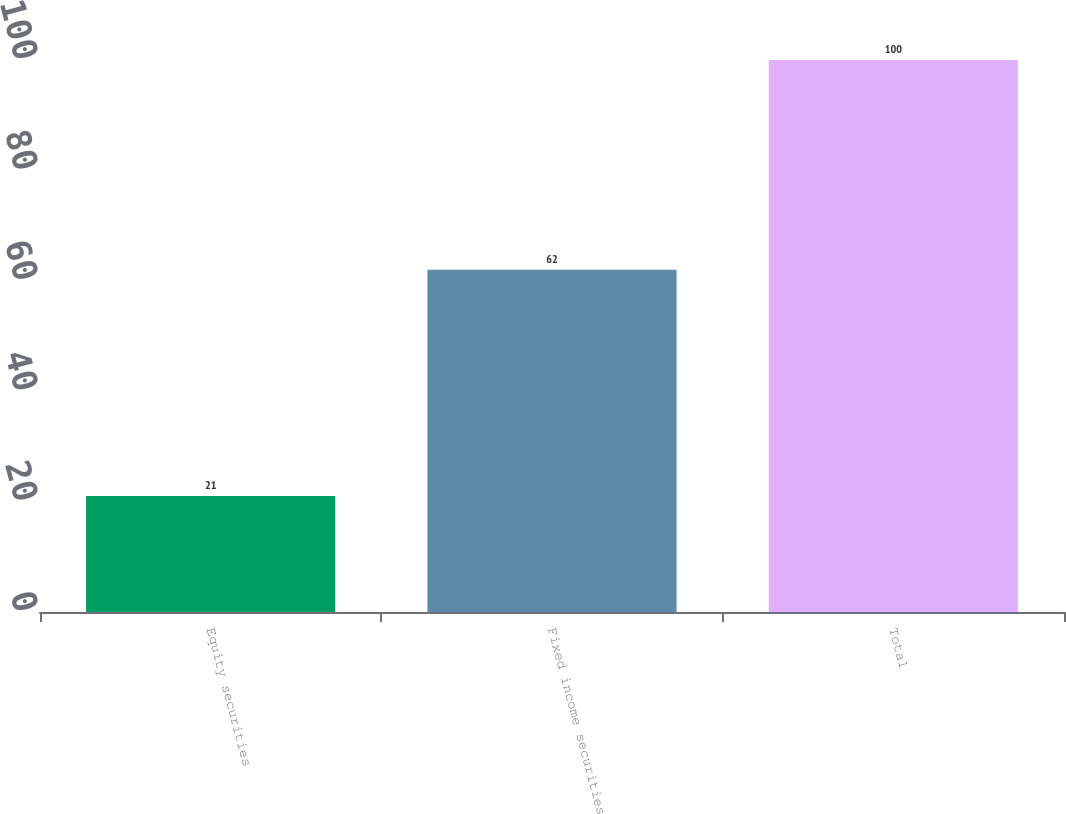<chart> <loc_0><loc_0><loc_500><loc_500><bar_chart><fcel>Equity securities<fcel>Fixed income securities<fcel>Total<nl><fcel>21<fcel>62<fcel>100<nl></chart> 